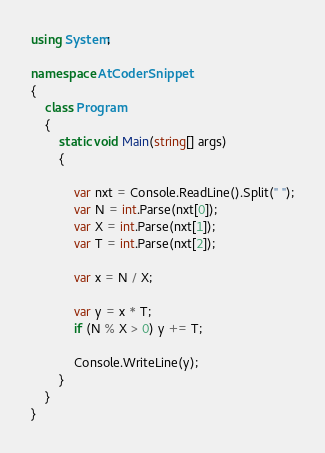Convert code to text. <code><loc_0><loc_0><loc_500><loc_500><_C#_>using System;

namespace AtCoderSnippet
{
    class Program
    {
        static void Main(string[] args)
        {

            var nxt = Console.ReadLine().Split(" ");
            var N = int.Parse(nxt[0]);
            var X = int.Parse(nxt[1]);
            var T = int.Parse(nxt[2]);

            var x = N / X;
            
            var y = x * T;
            if (N % X > 0) y += T;

            Console.WriteLine(y);
        }
    }
}
</code> 